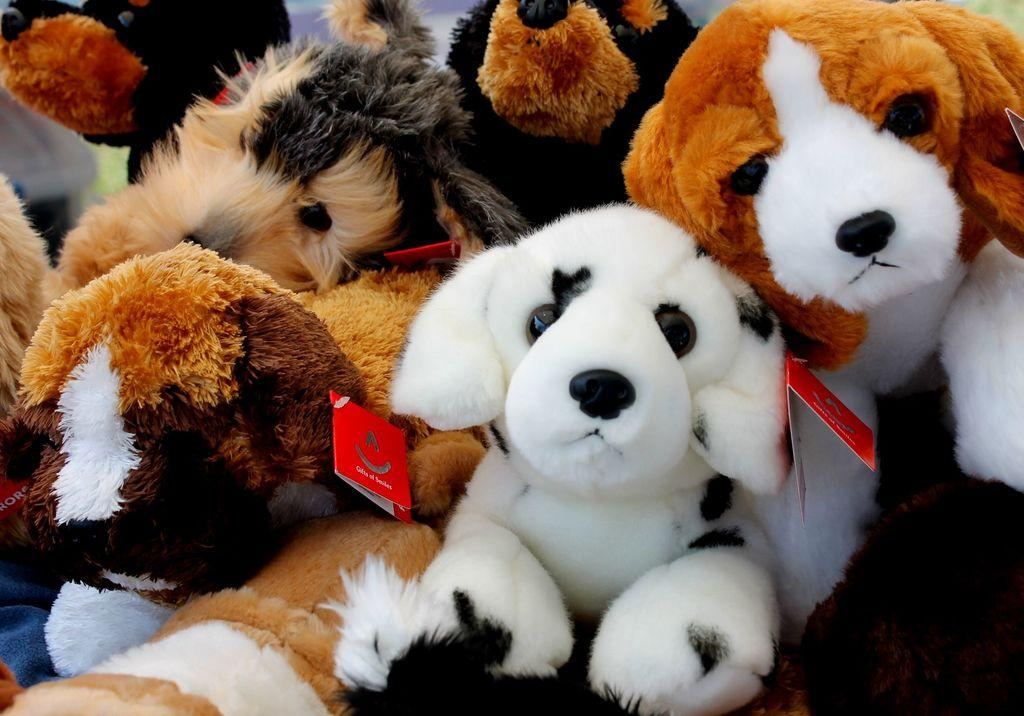What type of toys are present in the image? There are toys of dogs in the image. Are there any additional features on the toys? Yes, the toys have tags attached to them. What type of frog can be seen in the image? There is no frog present in the image; it features toys of dogs with tags. What caption is written on the toys in the image? There is no caption present on the toys in the image; they only have tags attached to them. 